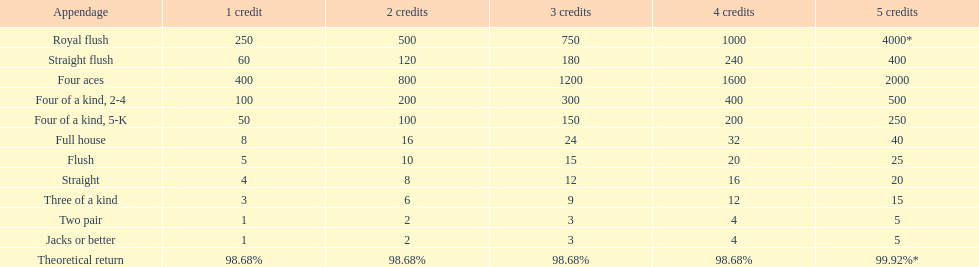Can you parse all the data within this table? {'header': ['Appendage', '1 credit', '2 credits', '3 credits', '4 credits', '5 credits'], 'rows': [['Royal flush', '250', '500', '750', '1000', '4000*'], ['Straight flush', '60', '120', '180', '240', '400'], ['Four aces', '400', '800', '1200', '1600', '2000'], ['Four of a kind, 2-4', '100', '200', '300', '400', '500'], ['Four of a kind, 5-K', '50', '100', '150', '200', '250'], ['Full house', '8', '16', '24', '32', '40'], ['Flush', '5', '10', '15', '20', '25'], ['Straight', '4', '8', '12', '16', '20'], ['Three of a kind', '3', '6', '9', '12', '15'], ['Two pair', '1', '2', '3', '4', '5'], ['Jacks or better', '1', '2', '3', '4', '5'], ['Theoretical return', '98.68%', '98.68%', '98.68%', '98.68%', '99.92%*']]} How many credits do you have to spend to get at least 2000 in payout if you had four aces? 5 credits. 